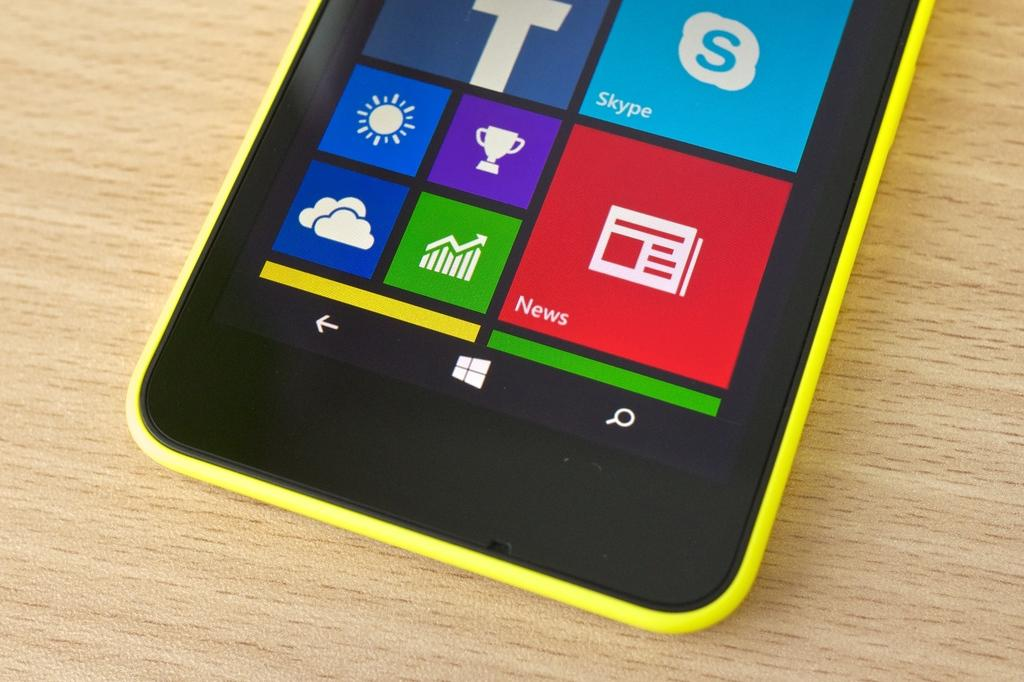Provide a one-sentence caption for the provided image. A yellow cell phone with large icons rests on a table. 